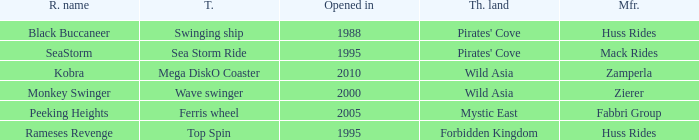Which ride opened after the 2000 Peeking Heights? Ferris wheel. 